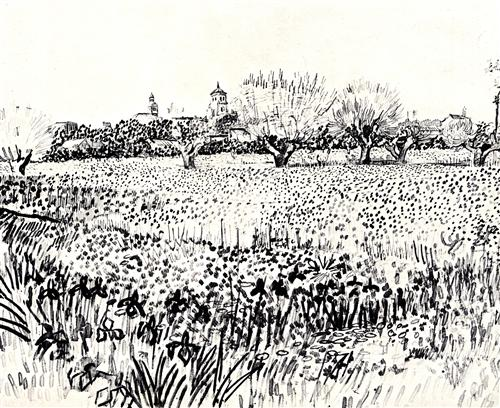Imagine you are a traveler coming across this scene for the first time. Describe your thoughts and feelings. As a weary traveler, I stumble upon this serene and picturesque landscape almost by accident. The expanse of tall grasses and wildflowers sways gently in the breeze, creating a soothing rustle that immediately eases the fatigue in my bones. The houses with their pointed roofs and the row of bare-branched trees evoke a sense of nostalgia, reminding me of simpler, peaceful times. The delicate clouds drifting lazily in the sky add to the serenity, making me feel like I've stepped into a different world where time moves slowly, inviting me to pause, breathe, and take in the quiet beauty. 